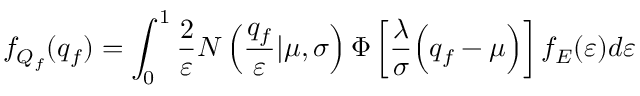Convert formula to latex. <formula><loc_0><loc_0><loc_500><loc_500>f _ { Q _ { f } } ( q _ { f } ) = \int _ { 0 } ^ { 1 } \frac { 2 } { \varepsilon } N \left ( \frac { q _ { f } } { \varepsilon } | \mu , \sigma \right ) \Phi \left [ \frac { \lambda } { \sigma } \left ( q _ { f } - \mu \right ) \right ] f _ { E } ( \varepsilon ) d \varepsilon</formula> 